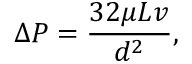Convert formula to latex. <formula><loc_0><loc_0><loc_500><loc_500>\Delta P = { \frac { 3 2 \mu L v } { d ^ { 2 } } } ,</formula> 